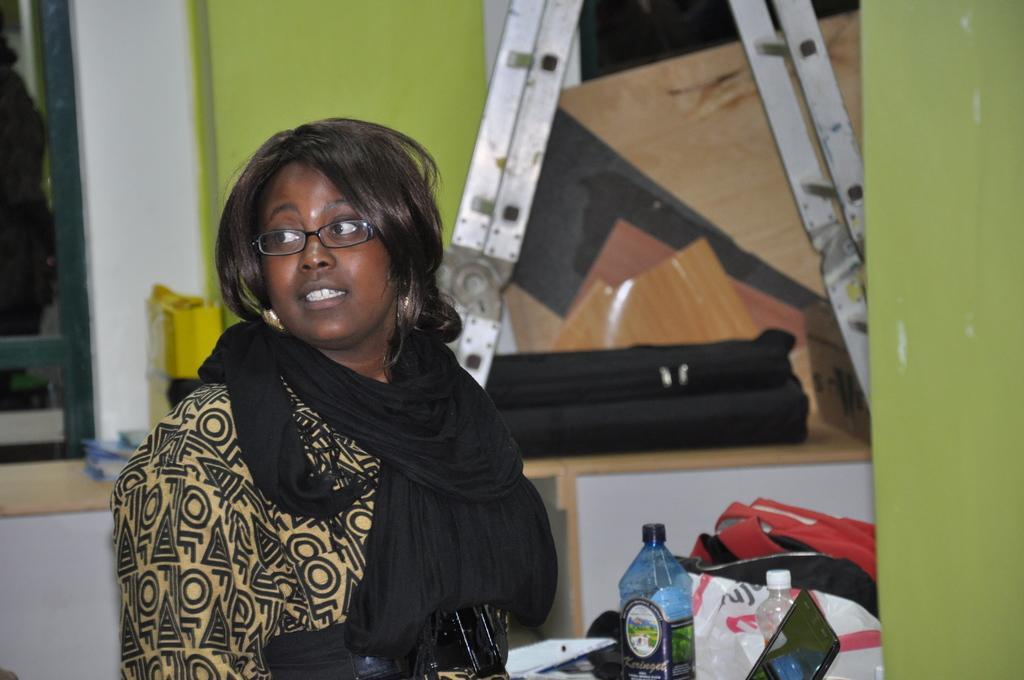Can you describe this image briefly? The center of the image, we can see a woman. She wear a yellow and black color combination dress. On his neck, she wear a black color scarf. In-front of her, we can see bottle, sticker on it. Here we can see screen laptop. Where bags are placed. The background, we can see wooden cupboards, and green color wall here. On left side of the image, we can found a mirror. And she wear a glasses. 